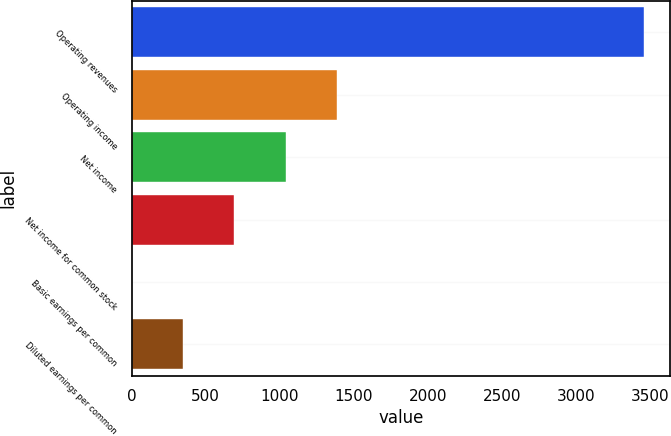Convert chart. <chart><loc_0><loc_0><loc_500><loc_500><bar_chart><fcel>Operating revenues<fcel>Operating income<fcel>Net income<fcel>Net income for common stock<fcel>Basic earnings per common<fcel>Diluted earnings per common<nl><fcel>3462<fcel>1385.28<fcel>1039.16<fcel>693.04<fcel>0.8<fcel>346.92<nl></chart> 